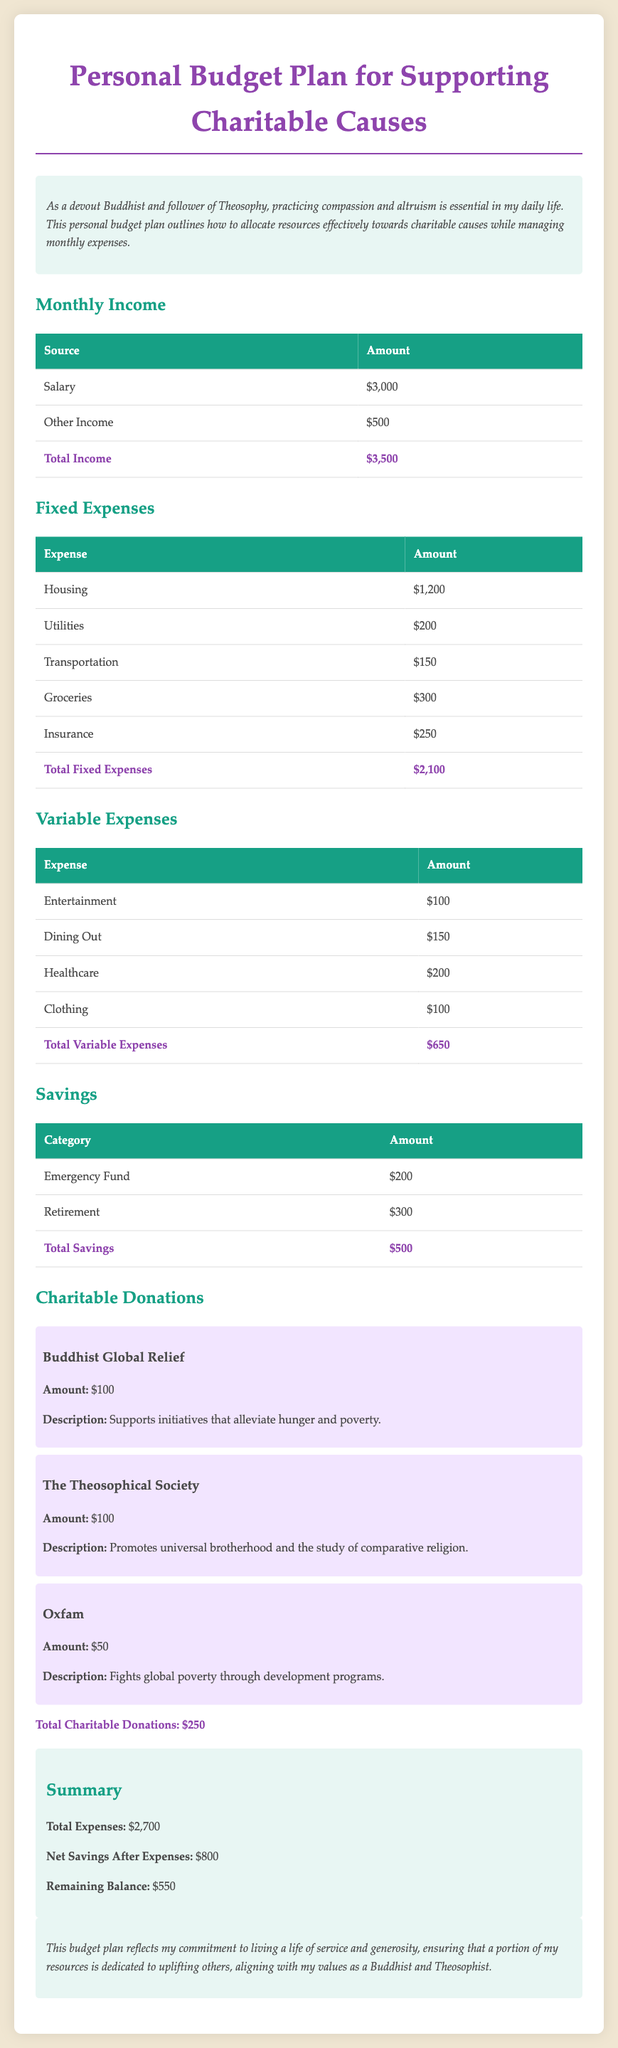What is the total monthly income? The total monthly income is calculated by adding the salary and other income, which is $3000 + $500 = $3500.
Answer: $3500 What is the total amount allocated for entertainment? The total allocated for entertainment is shown in the variable expenses section, which is $100.
Answer: $100 How much is donated to Oxfam? The amount donated to Oxfam is specifically listed in the charitable donations section of the document, which is $50.
Answer: $50 What are the total fixed expenses? The total fixed expenses are the sum of all fixed expense items in the document, which is $1200 + $200 + $150 + $300 + $250 = $2100.
Answer: $2100 What is the remaining balance after expenses? The remaining balance is calculated by subtracting total expenses from monthly income: $3500 - $2700 = $800.
Answer: $800 What percentage of the total monthly income is dedicated to charitable donations? The percentage is calculated by dividing total donations by total income: ($250 / $3500) * 100 = approximately 7.14%.
Answer: 7.14% How many charitable causes are supported in this plan? The number of charitable causes is identified in the donations section, which lists three different organizations.
Answer: Three What is the total amount saved for retirement? The total amount saved for retirement is provided in the savings section, which is $300.
Answer: $300 What is the overall theme of this budget plan? The overall theme reflects a commitment to altruism and effective resource allocation towards charitable causes alongside personal expenses.
Answer: Altruism 